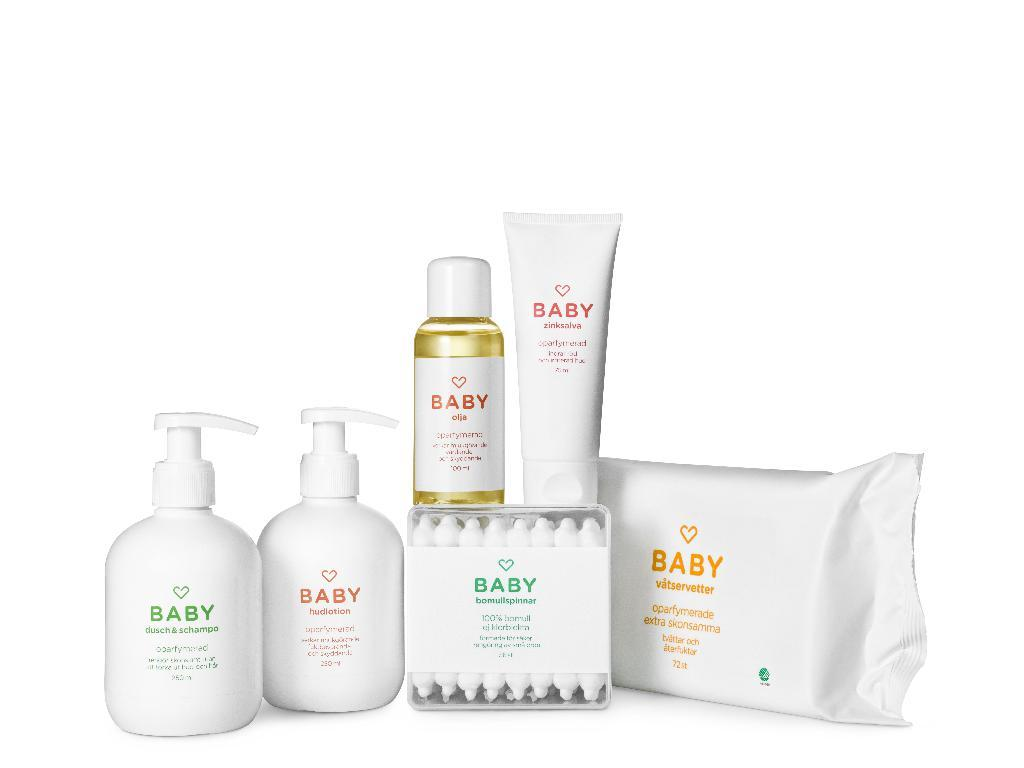<image>
Share a concise interpretation of the image provided. Numerous products from Baby such as shampoo and wipes. 